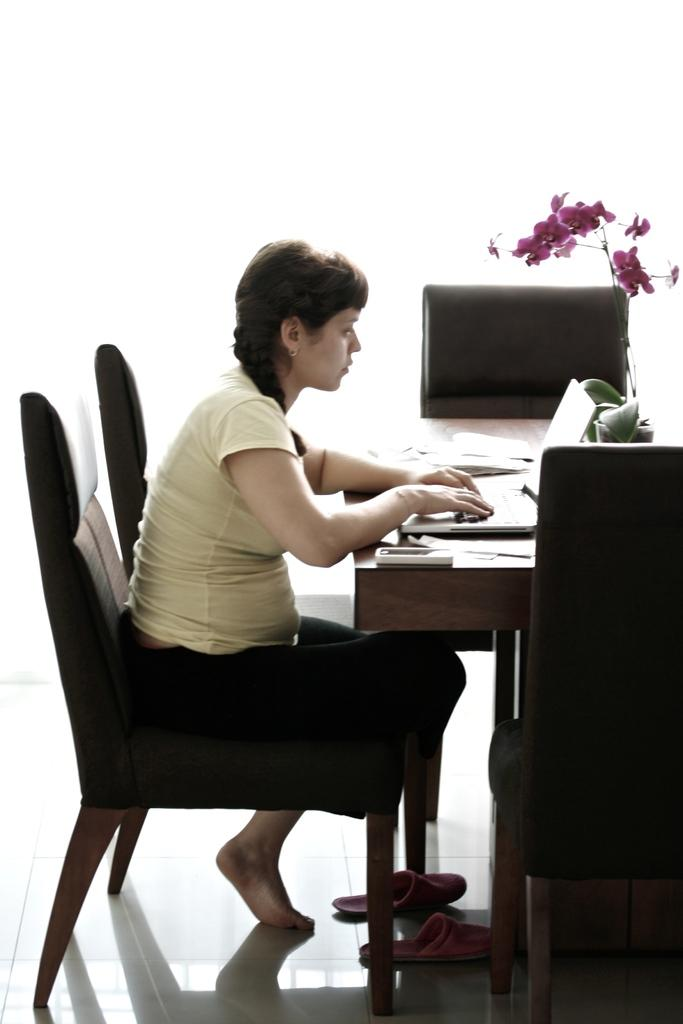Who is the main subject in the image? There is a woman in the image. What is the woman doing in the image? The woman is sitting on a chair. What is in front of the woman? There is a table in front of the woman. What can be seen on the table? There are objects on the table. What type of magic is the woman performing on the soda in the image? There is no soda or magic present in the image. The woman is simply sitting on a chair with a table in front of her. 